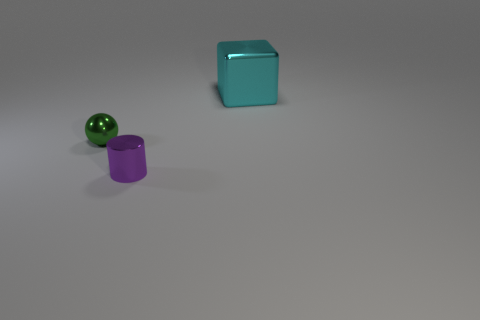Add 1 yellow matte objects. How many objects exist? 4 Subtract all cylinders. How many objects are left? 2 Subtract all tiny things. Subtract all small blue metal cylinders. How many objects are left? 1 Add 1 big cyan metal blocks. How many big cyan metal blocks are left? 2 Add 2 gray metallic blocks. How many gray metallic blocks exist? 2 Subtract 0 red cylinders. How many objects are left? 3 